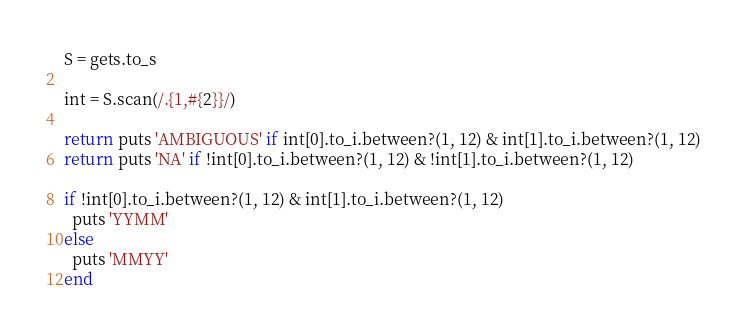<code> <loc_0><loc_0><loc_500><loc_500><_Ruby_>S = gets.to_s

int = S.scan(/.{1,#{2}}/)

return puts 'AMBIGUOUS' if int[0].to_i.between?(1, 12) & int[1].to_i.between?(1, 12)
return puts 'NA' if !int[0].to_i.between?(1, 12) & !int[1].to_i.between?(1, 12)

if !int[0].to_i.between?(1, 12) & int[1].to_i.between?(1, 12)
  puts 'YYMM'
else
  puts 'MMYY'
end</code> 